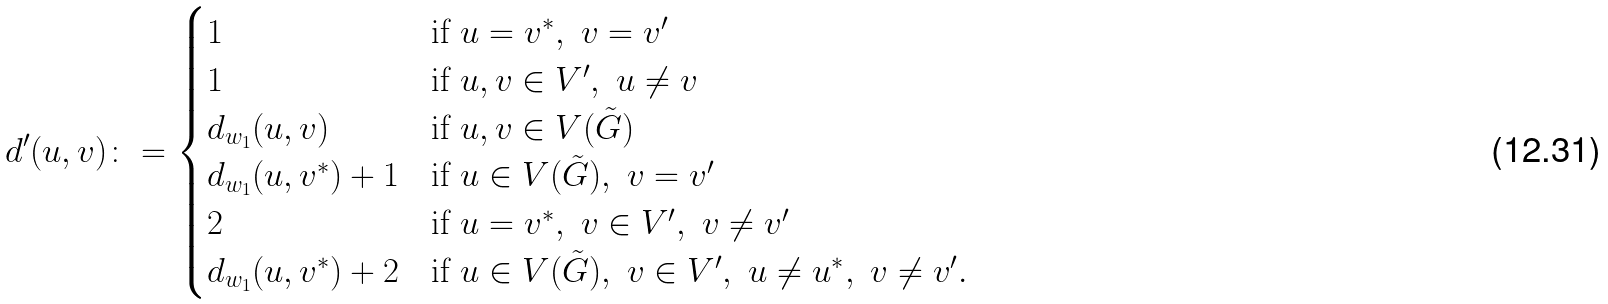<formula> <loc_0><loc_0><loc_500><loc_500>d ^ { \prime } ( u , v ) \colon = \begin{cases} 1 & \text {if } u = v ^ { * } , \ v = v ^ { \prime } \\ 1 & \text {if } u , v \in V ^ { \prime } , \ u \ne v \\ d _ { w _ { 1 } } ( u , v ) & \text {if } u , v \in V ( \tilde { G } ) \\ d _ { w _ { 1 } } ( u , v ^ { * } ) + 1 & \text {if } u \in V ( \tilde { G } ) , \ v = v ^ { \prime } \\ 2 & \text {if } u = v ^ { * } , \ v \in V ^ { \prime } , \ v \ne v ^ { \prime } \\ d _ { w _ { 1 } } ( u , v ^ { * } ) + 2 & \text {if } u \in V ( \tilde { G } ) , \ v \in V ^ { \prime } , \ u \ne u ^ { * } , \ v \ne v ^ { \prime } . \end{cases}</formula> 